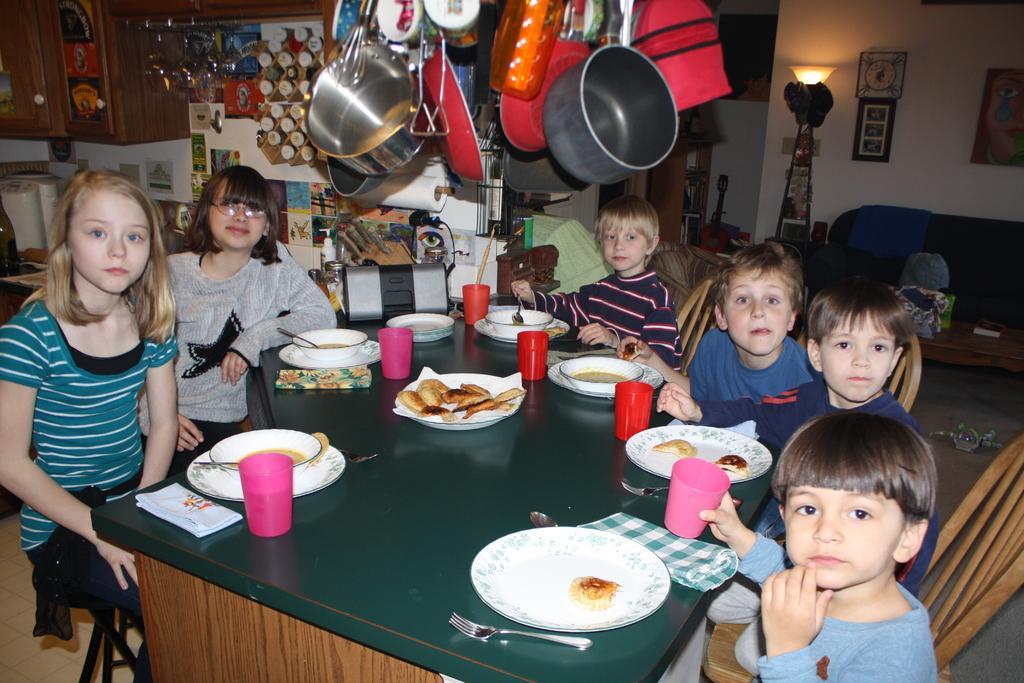In one or two sentences, can you explain what this image depicts? There is a dining table on which plates are placed along with bowls and glasses. kids sitting around the table on chair. there is a sofa near the wall. A wall clock mounted on the wall along with a lamp. There are bowls and vessels which are hanging. This is a kitchen. 